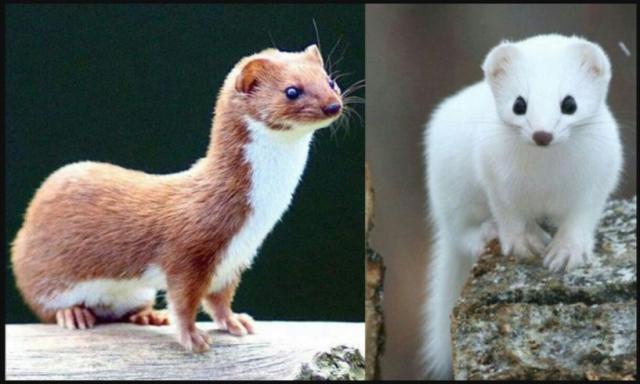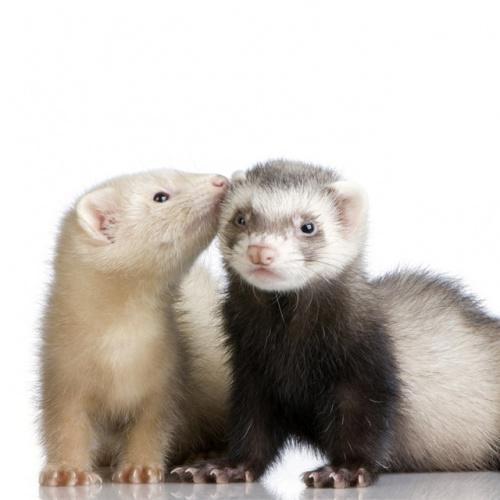The first image is the image on the left, the second image is the image on the right. Assess this claim about the two images: "At least 1 of the animals is standing outdoors.". Correct or not? Answer yes or no. Yes. 